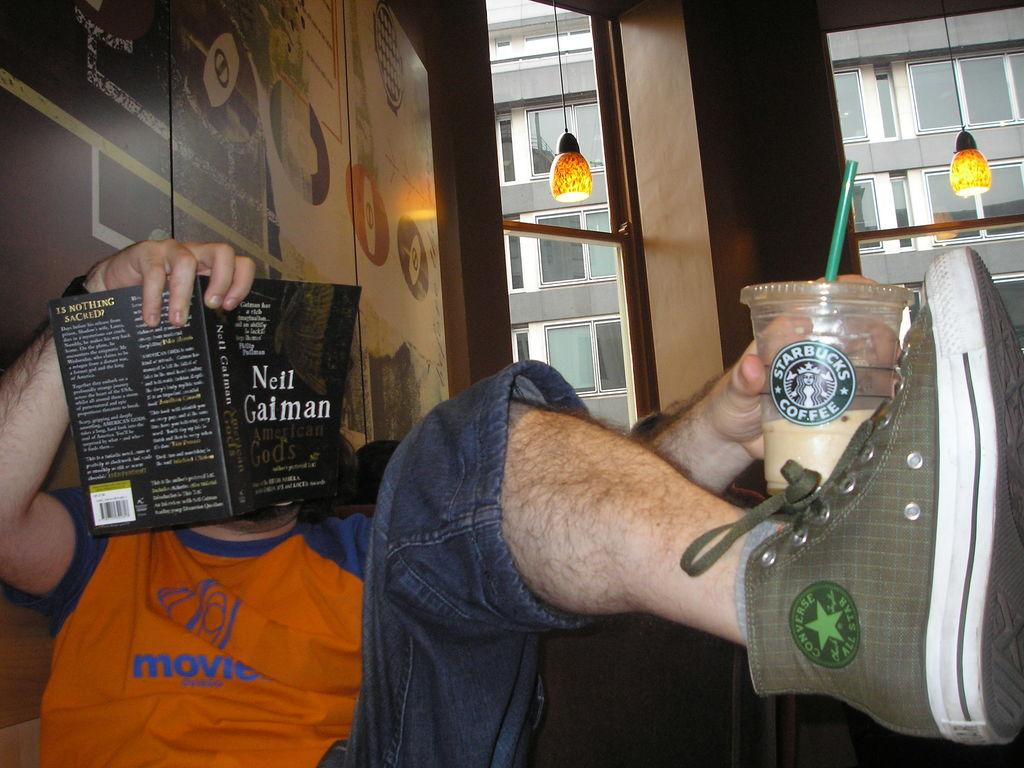<image>
Present a compact description of the photo's key features. A man holding a Starbucks cup reading a black book. 